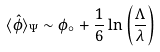Convert formula to latex. <formula><loc_0><loc_0><loc_500><loc_500>\langle \hat { \phi } \rangle _ { \Psi } \sim \phi _ { \circ } + \frac { 1 } { 6 } \ln \left ( \frac { \Lambda } { \lambda } \right )</formula> 